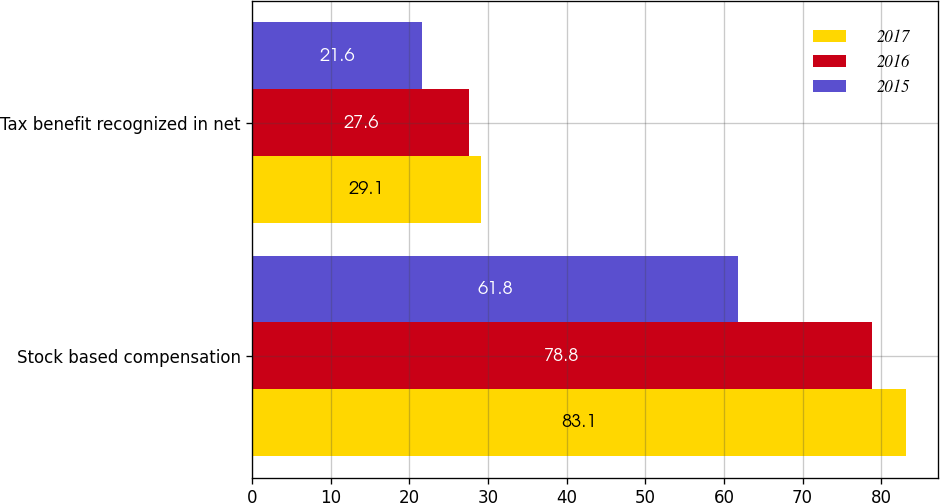Convert chart to OTSL. <chart><loc_0><loc_0><loc_500><loc_500><stacked_bar_chart><ecel><fcel>Stock based compensation<fcel>Tax benefit recognized in net<nl><fcel>2017<fcel>83.1<fcel>29.1<nl><fcel>2016<fcel>78.8<fcel>27.6<nl><fcel>2015<fcel>61.8<fcel>21.6<nl></chart> 